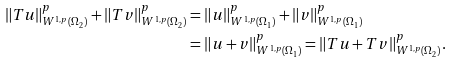<formula> <loc_0><loc_0><loc_500><loc_500>\| T u \| _ { W ^ { 1 , p } ( \Omega _ { 2 } ) } ^ { p } + \| T v \| _ { W ^ { 1 , p } ( \Omega _ { 2 } ) } ^ { p } & = \| u \| _ { W ^ { 1 , p } ( \Omega _ { 1 } ) } ^ { p } + \| v \| _ { W ^ { 1 , p } ( \Omega _ { 1 } ) } ^ { p } \\ & = \| u + v \| ^ { p } _ { W ^ { 1 , p } ( \Omega _ { 1 } ) } = \| T u + T v \| ^ { p } _ { W ^ { 1 , p } ( \Omega _ { 2 } ) } .</formula> 